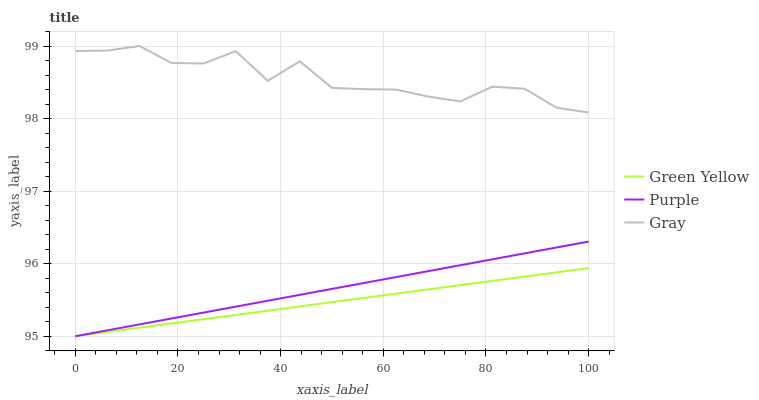Does Green Yellow have the minimum area under the curve?
Answer yes or no. Yes. Does Gray have the maximum area under the curve?
Answer yes or no. Yes. Does Gray have the minimum area under the curve?
Answer yes or no. No. Does Green Yellow have the maximum area under the curve?
Answer yes or no. No. Is Purple the smoothest?
Answer yes or no. Yes. Is Gray the roughest?
Answer yes or no. Yes. Is Green Yellow the smoothest?
Answer yes or no. No. Is Green Yellow the roughest?
Answer yes or no. No. Does Purple have the lowest value?
Answer yes or no. Yes. Does Gray have the lowest value?
Answer yes or no. No. Does Gray have the highest value?
Answer yes or no. Yes. Does Green Yellow have the highest value?
Answer yes or no. No. Is Green Yellow less than Gray?
Answer yes or no. Yes. Is Gray greater than Green Yellow?
Answer yes or no. Yes. Does Green Yellow intersect Purple?
Answer yes or no. Yes. Is Green Yellow less than Purple?
Answer yes or no. No. Is Green Yellow greater than Purple?
Answer yes or no. No. Does Green Yellow intersect Gray?
Answer yes or no. No. 